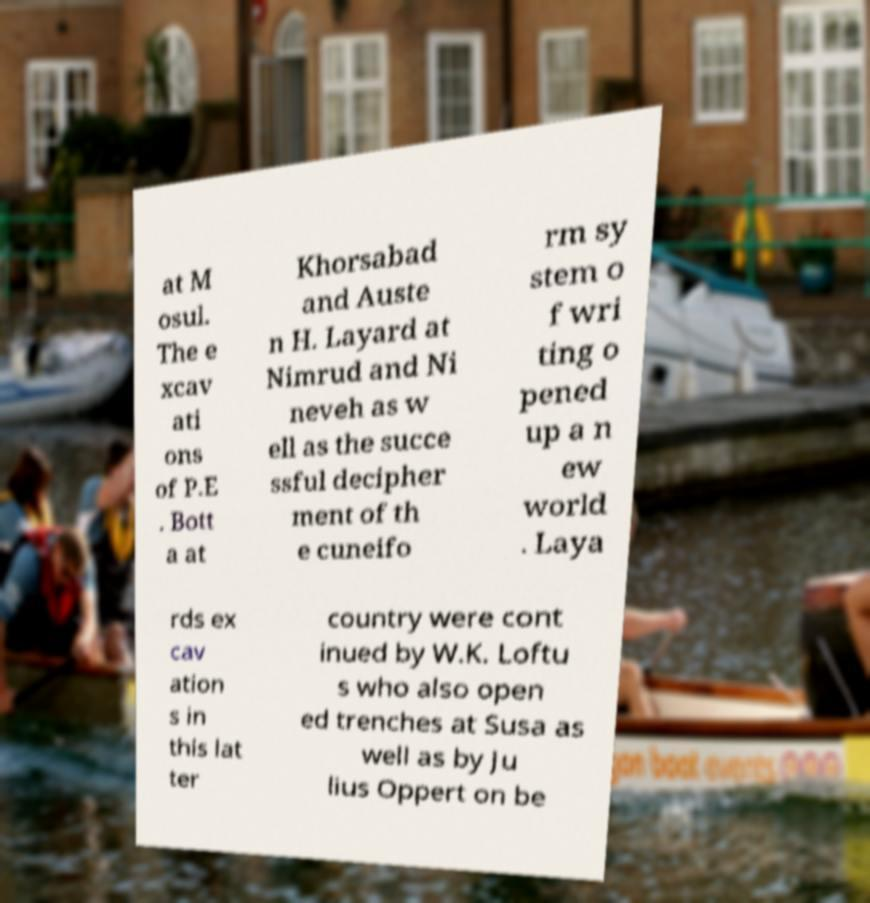I need the written content from this picture converted into text. Can you do that? at M osul. The e xcav ati ons of P.E . Bott a at Khorsabad and Auste n H. Layard at Nimrud and Ni neveh as w ell as the succe ssful decipher ment of th e cuneifo rm sy stem o f wri ting o pened up a n ew world . Laya rds ex cav ation s in this lat ter country were cont inued by W.K. Loftu s who also open ed trenches at Susa as well as by Ju lius Oppert on be 